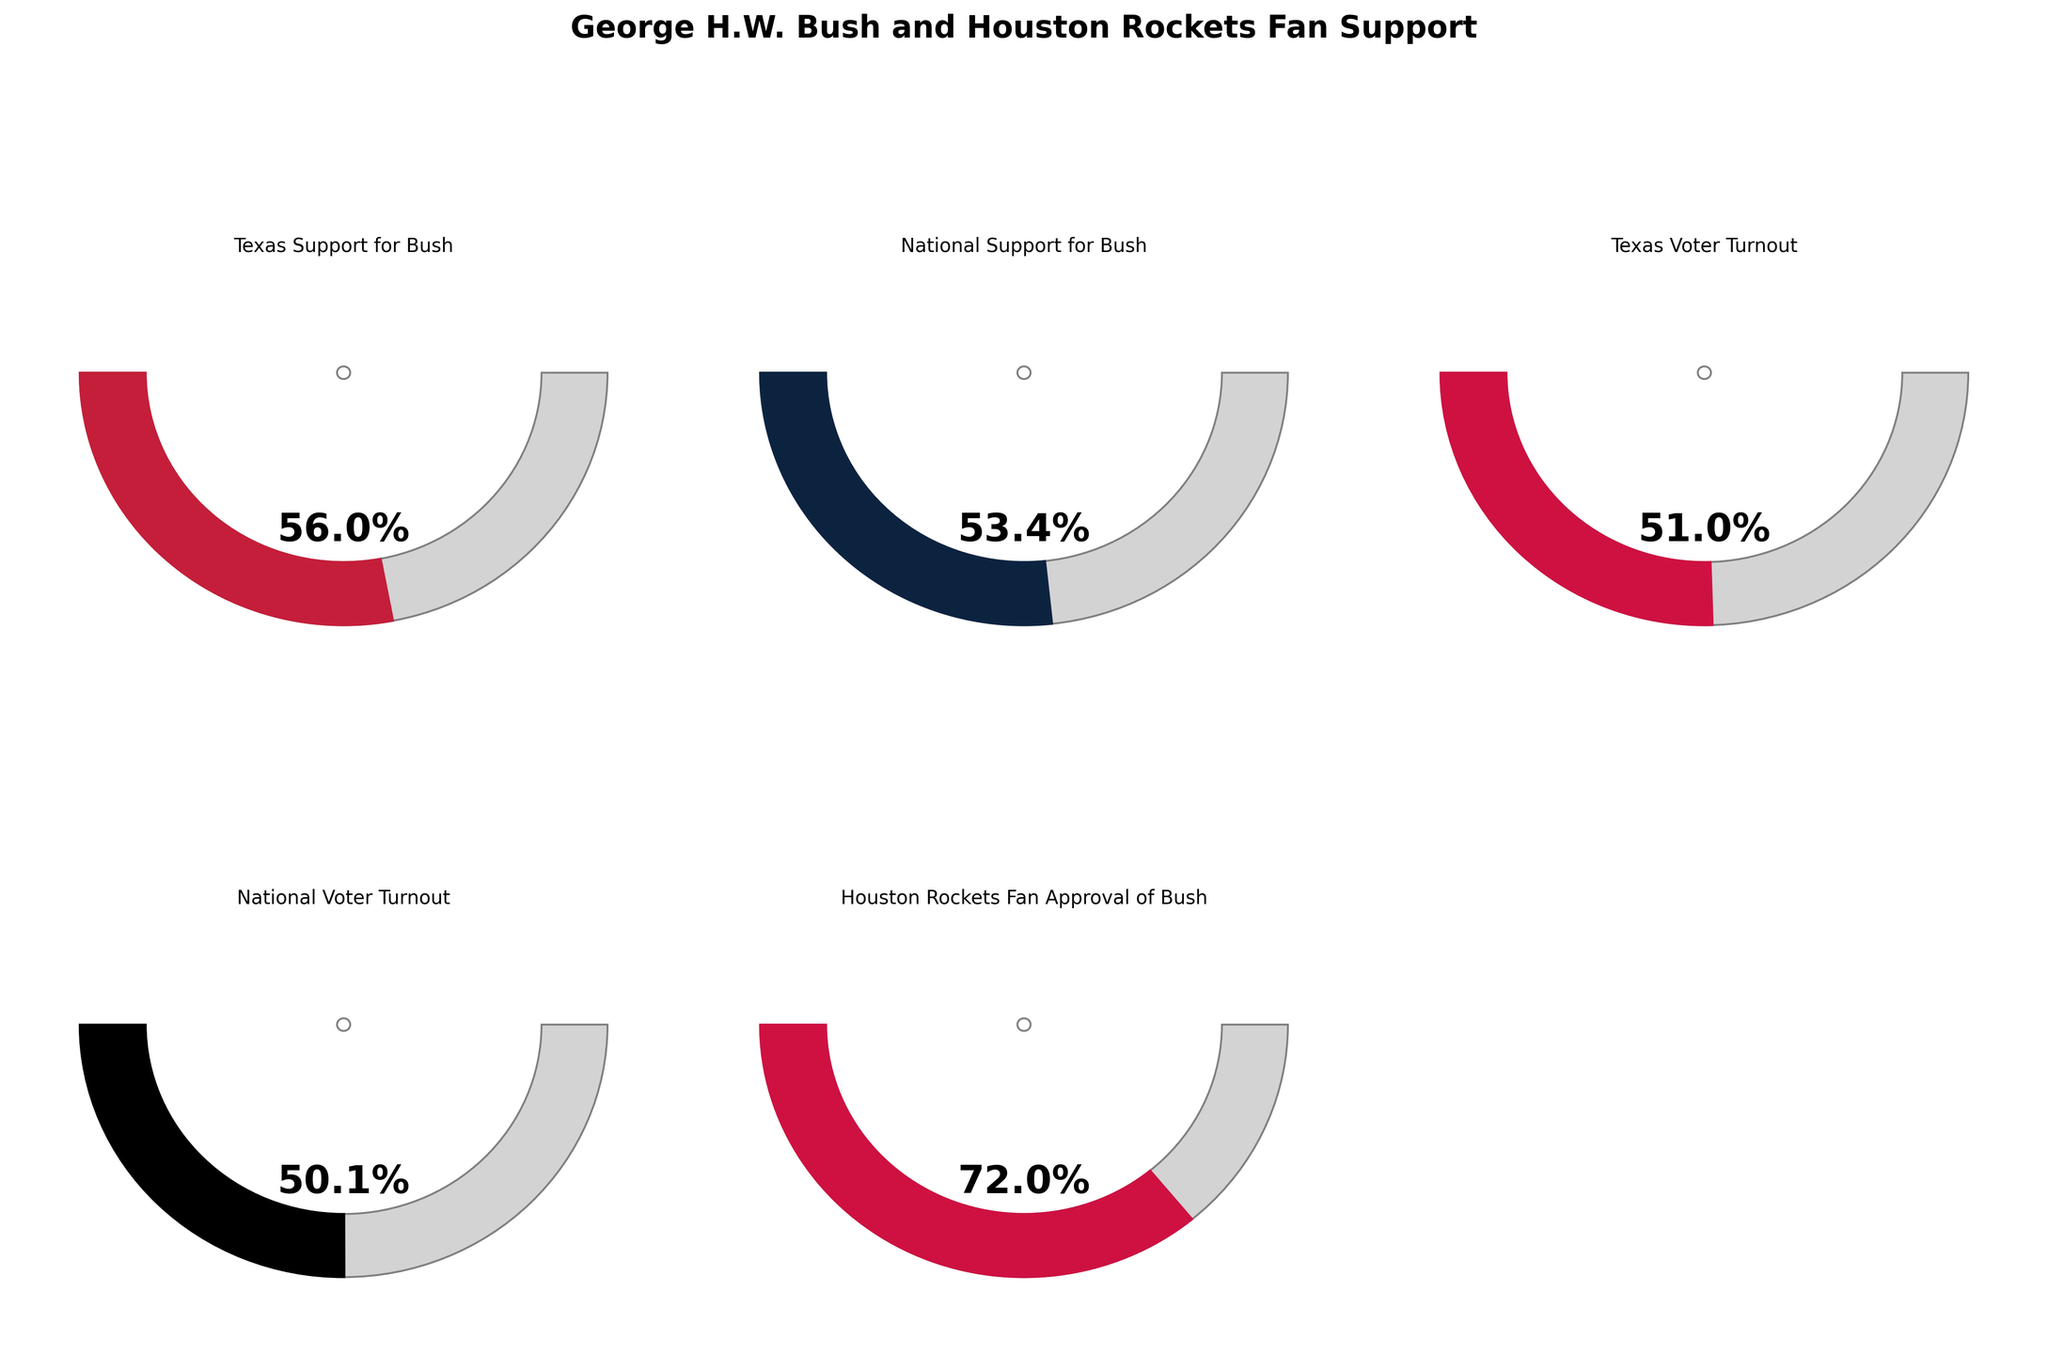What's the percentage of Texas voters who supported George H.W. Bush in the 1988 presidential election? The gauge chart for 'Texas Support for Bush' shows the completion level and the labeled text in the chart reads "56%".
Answer: 56% What is the relationship between the Texas support for Bush and the national support? By comparing the gauge charts labeled 'Texas Support for Bush' and 'National Support for Bush', it's clear that Texas has a higher percentage (56%) compared to the national level (53.4%).
Answer: Texas support is higher Which category has the highest percentage value among the displayed values? The gauge chart labeled 'Houston Rockets Fan Approval of Bush' shows the highest percentage value of 72%.
Answer: Houston Rockets Fan Approval of Bush What's the difference in voter turnout between Texas and the national average in the 1988 presidential election? Comparing the 'Texas Voter Turnout' gauge (51%) and 'National Voter Turnout' gauge (50.1%), the difference is calculated as 51 - 50.1.
Answer: 0.9% How does the Houston Rockets fan approval of Bush compare to the national voter turnout? Looking at the gauge charts, 'Houston Rockets Fan Approval of Bush' is significantly higher at 72% compared to 'National Voter Turnout' at 50.1%.
Answer: Rockets approval is higher by 21.9% What is the average percentage of support for Bush between Texas and the national level? The gauge charts show 'Texas Support for Bush' (56%) and 'National Support for Bush' (53.4%). The average is calculated as (56 + 53.4) / 2.
Answer: 54.7% How much greater is the Houston Rockets fan approval of Bush compared to Texas voter turnout? The 'Houston Rockets Fan Approval of Bush' gauge shows 72%, while the 'Texas Voter Turnout' shows 51%. The difference is calculated as 72 - 51.
Answer: 21% Which category has the smallest percentage value? The gauge chart labeled 'National Voter Turnout' shows the lowest percentage value of 50.1%.
Answer: National Voter Turnout 